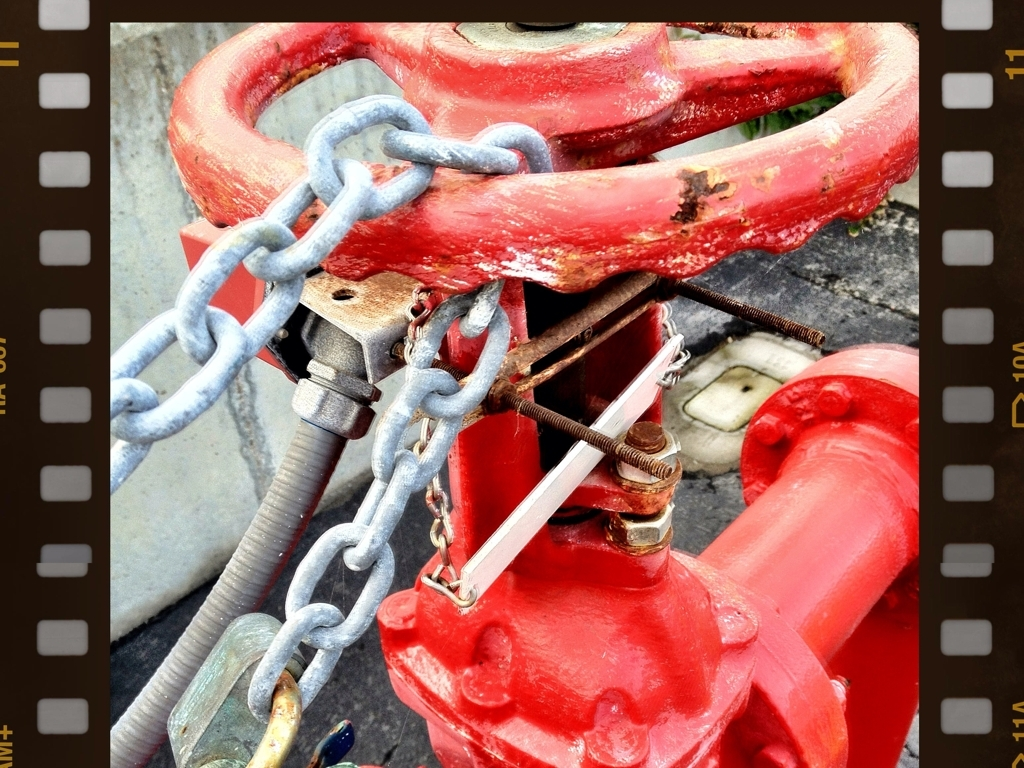Can you speculate why the fire hydrant has multiple colors? The fire hydrant exhibits layers of paint and some rust, hinting at its age and the maintenance it has received over time. The presence of multiple colors, primarily red with spots of different shades, suggests that it has been repainted perhaps to maintain visibility and protection against weathering. This is a common practice to keep hydrants serviceable and easily identifiable for firefighters. 